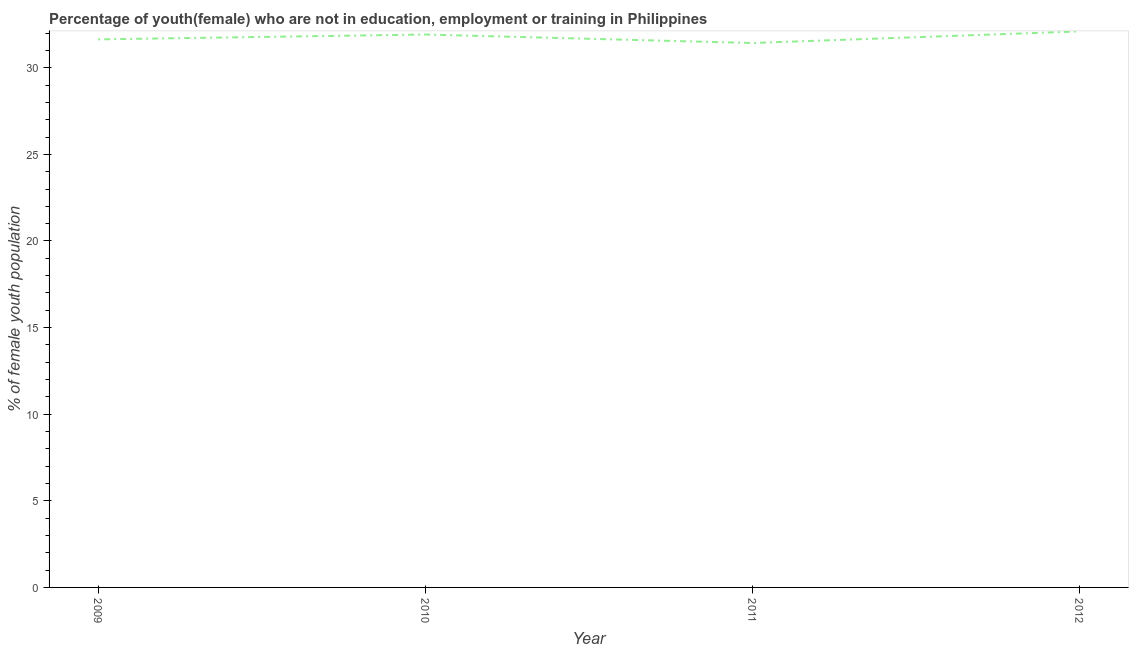What is the unemployed female youth population in 2010?
Keep it short and to the point. 31.92. Across all years, what is the maximum unemployed female youth population?
Keep it short and to the point. 32.1. Across all years, what is the minimum unemployed female youth population?
Give a very brief answer. 31.43. What is the sum of the unemployed female youth population?
Offer a terse response. 127.09. What is the difference between the unemployed female youth population in 2009 and 2012?
Provide a short and direct response. -0.46. What is the average unemployed female youth population per year?
Make the answer very short. 31.77. What is the median unemployed female youth population?
Offer a terse response. 31.78. What is the ratio of the unemployed female youth population in 2009 to that in 2012?
Ensure brevity in your answer.  0.99. Is the difference between the unemployed female youth population in 2009 and 2012 greater than the difference between any two years?
Keep it short and to the point. No. What is the difference between the highest and the second highest unemployed female youth population?
Your answer should be compact. 0.18. Is the sum of the unemployed female youth population in 2009 and 2011 greater than the maximum unemployed female youth population across all years?
Offer a terse response. Yes. What is the difference between the highest and the lowest unemployed female youth population?
Your response must be concise. 0.67. What is the difference between two consecutive major ticks on the Y-axis?
Your answer should be compact. 5. What is the title of the graph?
Provide a short and direct response. Percentage of youth(female) who are not in education, employment or training in Philippines. What is the label or title of the X-axis?
Provide a short and direct response. Year. What is the label or title of the Y-axis?
Offer a terse response. % of female youth population. What is the % of female youth population of 2009?
Ensure brevity in your answer.  31.64. What is the % of female youth population of 2010?
Your answer should be compact. 31.92. What is the % of female youth population of 2011?
Make the answer very short. 31.43. What is the % of female youth population in 2012?
Your answer should be very brief. 32.1. What is the difference between the % of female youth population in 2009 and 2010?
Your answer should be very brief. -0.28. What is the difference between the % of female youth population in 2009 and 2011?
Keep it short and to the point. 0.21. What is the difference between the % of female youth population in 2009 and 2012?
Keep it short and to the point. -0.46. What is the difference between the % of female youth population in 2010 and 2011?
Ensure brevity in your answer.  0.49. What is the difference between the % of female youth population in 2010 and 2012?
Offer a terse response. -0.18. What is the difference between the % of female youth population in 2011 and 2012?
Your answer should be compact. -0.67. What is the ratio of the % of female youth population in 2009 to that in 2010?
Your response must be concise. 0.99. What is the ratio of the % of female youth population in 2010 to that in 2011?
Keep it short and to the point. 1.02. 